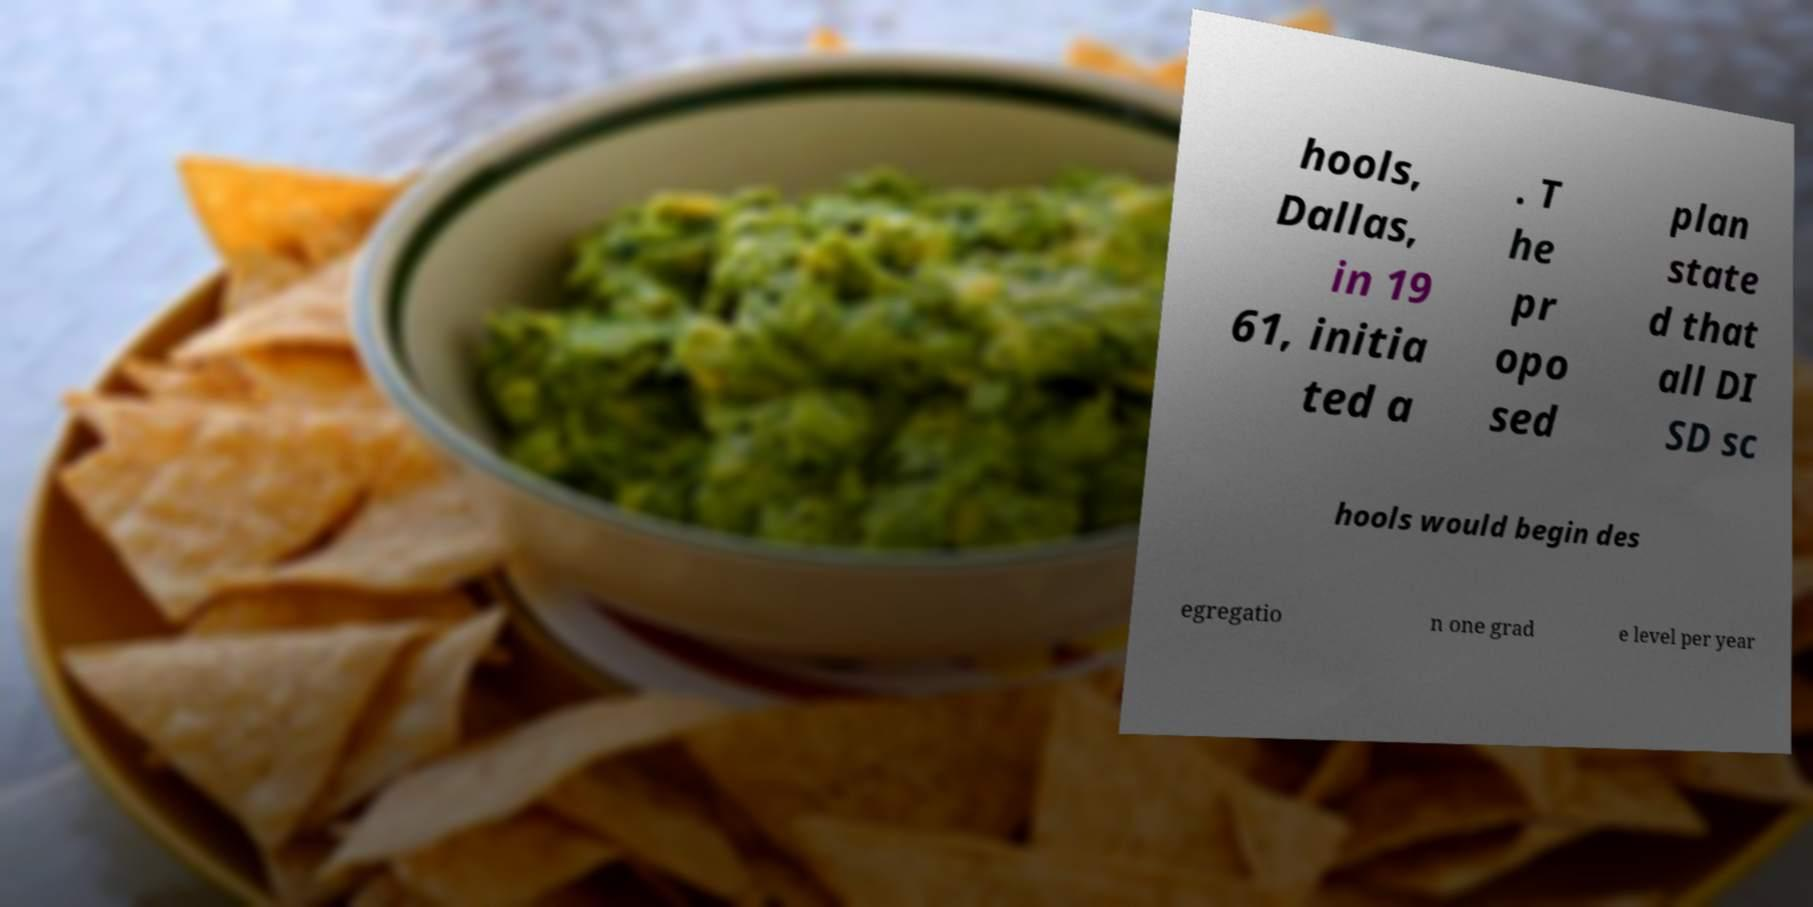There's text embedded in this image that I need extracted. Can you transcribe it verbatim? hools, Dallas, in 19 61, initia ted a . T he pr opo sed plan state d that all DI SD sc hools would begin des egregatio n one grad e level per year 